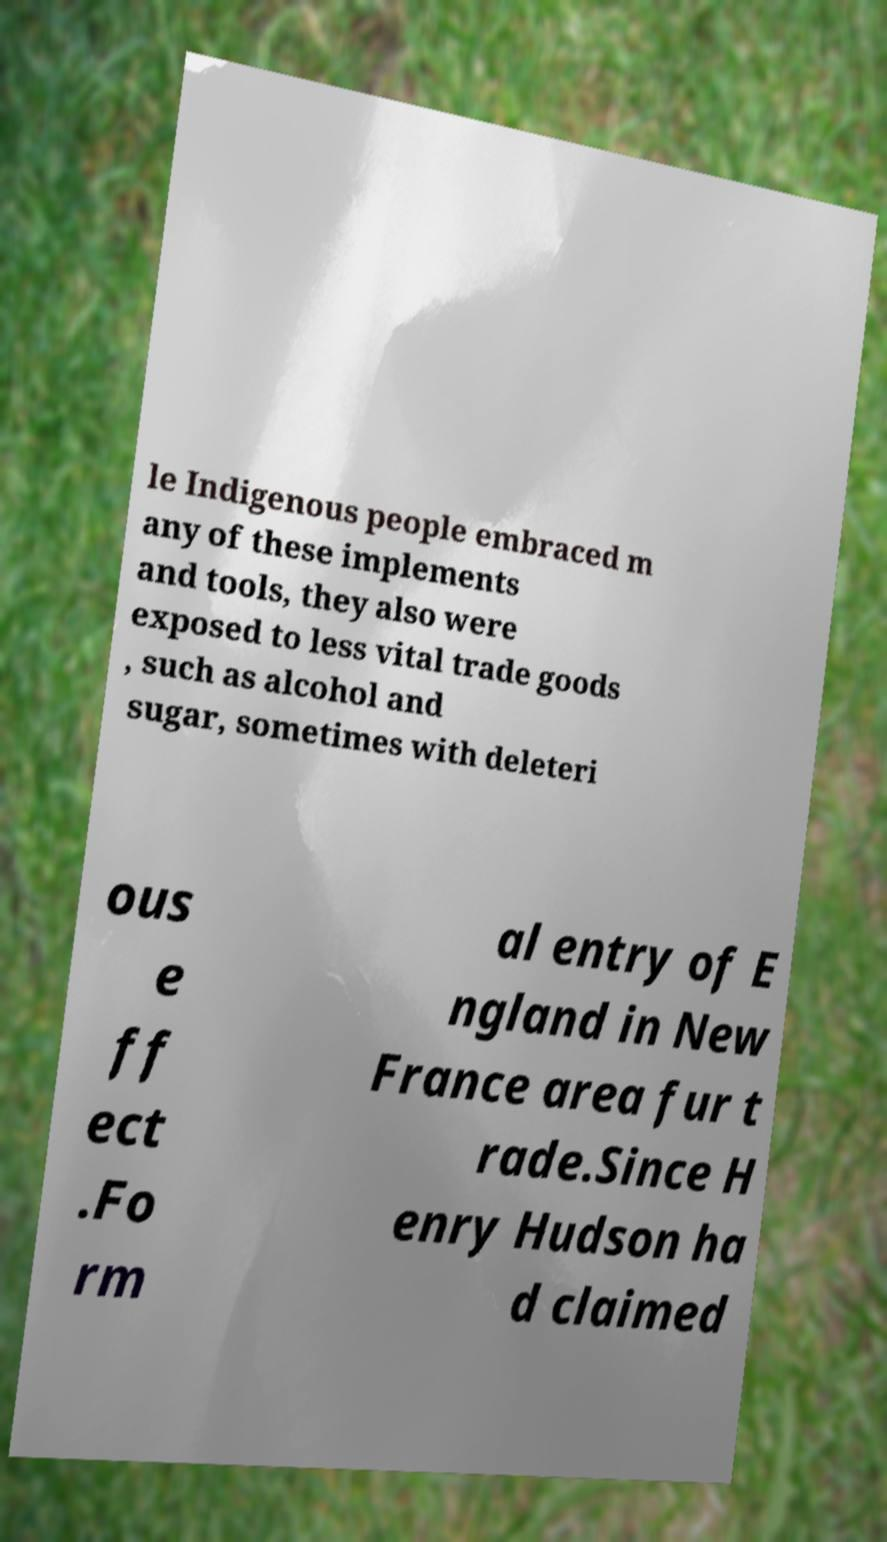What messages or text are displayed in this image? I need them in a readable, typed format. le Indigenous people embraced m any of these implements and tools, they also were exposed to less vital trade goods , such as alcohol and sugar, sometimes with deleteri ous e ff ect .Fo rm al entry of E ngland in New France area fur t rade.Since H enry Hudson ha d claimed 